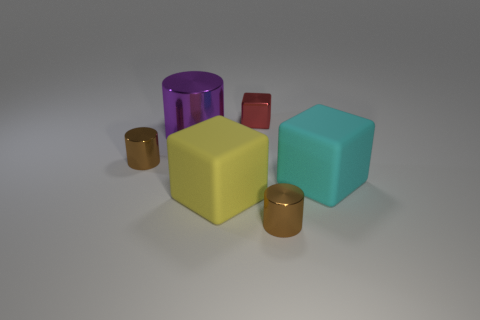Add 1 big shiny things. How many objects exist? 7 Subtract 0 brown spheres. How many objects are left? 6 Subtract all purple cubes. Subtract all tiny red things. How many objects are left? 5 Add 3 small things. How many small things are left? 6 Add 1 big cyan objects. How many big cyan objects exist? 2 